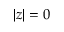Convert formula to latex. <formula><loc_0><loc_0><loc_500><loc_500>| z | = 0</formula> 